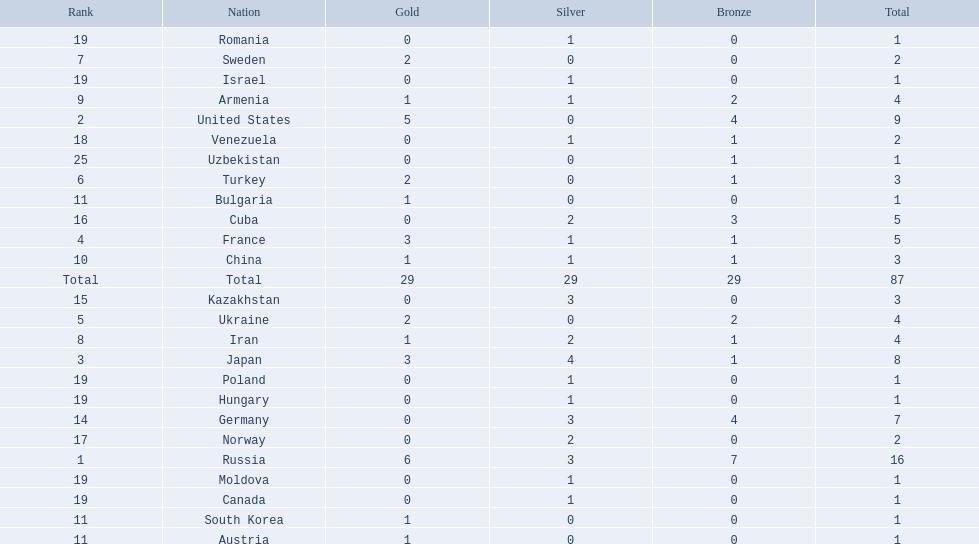How many countries competed? Israel. How many total medals did russia win? 16. What country won only 1 medal? Uzbekistan. 